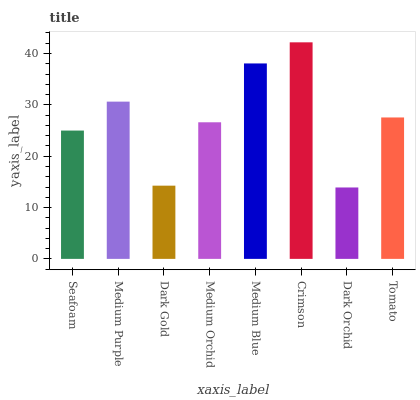Is Dark Orchid the minimum?
Answer yes or no. Yes. Is Crimson the maximum?
Answer yes or no. Yes. Is Medium Purple the minimum?
Answer yes or no. No. Is Medium Purple the maximum?
Answer yes or no. No. Is Medium Purple greater than Seafoam?
Answer yes or no. Yes. Is Seafoam less than Medium Purple?
Answer yes or no. Yes. Is Seafoam greater than Medium Purple?
Answer yes or no. No. Is Medium Purple less than Seafoam?
Answer yes or no. No. Is Tomato the high median?
Answer yes or no. Yes. Is Medium Orchid the low median?
Answer yes or no. Yes. Is Crimson the high median?
Answer yes or no. No. Is Tomato the low median?
Answer yes or no. No. 